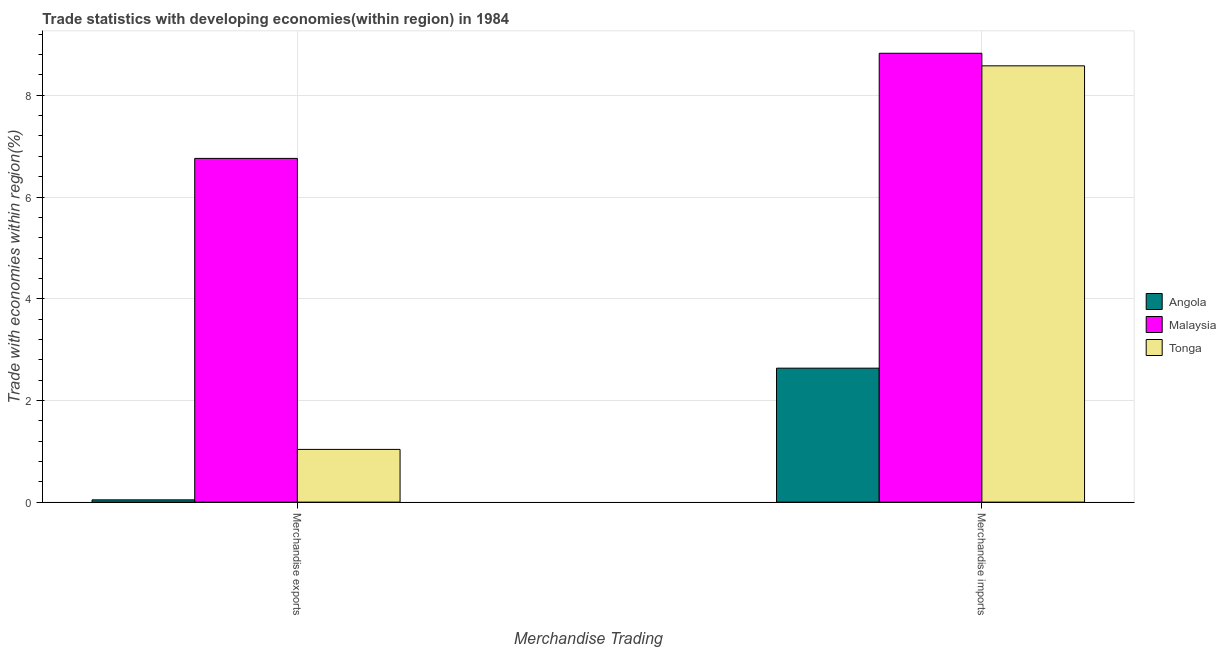How many different coloured bars are there?
Provide a succinct answer. 3. Are the number of bars per tick equal to the number of legend labels?
Ensure brevity in your answer.  Yes. How many bars are there on the 2nd tick from the left?
Ensure brevity in your answer.  3. How many bars are there on the 1st tick from the right?
Give a very brief answer. 3. What is the merchandise imports in Tonga?
Keep it short and to the point. 8.58. Across all countries, what is the maximum merchandise exports?
Ensure brevity in your answer.  6.76. Across all countries, what is the minimum merchandise imports?
Give a very brief answer. 2.63. In which country was the merchandise imports maximum?
Offer a very short reply. Malaysia. In which country was the merchandise exports minimum?
Provide a short and direct response. Angola. What is the total merchandise imports in the graph?
Your answer should be very brief. 20.04. What is the difference between the merchandise imports in Tonga and that in Angola?
Your response must be concise. 5.95. What is the difference between the merchandise imports in Angola and the merchandise exports in Malaysia?
Provide a succinct answer. -4.12. What is the average merchandise exports per country?
Give a very brief answer. 2.61. What is the difference between the merchandise exports and merchandise imports in Angola?
Give a very brief answer. -2.59. In how many countries, is the merchandise imports greater than 6 %?
Provide a succinct answer. 2. What is the ratio of the merchandise exports in Angola to that in Tonga?
Make the answer very short. 0.04. Is the merchandise exports in Malaysia less than that in Angola?
Your answer should be very brief. No. What does the 2nd bar from the left in Merchandise imports represents?
Your answer should be very brief. Malaysia. What does the 1st bar from the right in Merchandise exports represents?
Give a very brief answer. Tonga. How many countries are there in the graph?
Make the answer very short. 3. What is the difference between two consecutive major ticks on the Y-axis?
Your response must be concise. 2. Are the values on the major ticks of Y-axis written in scientific E-notation?
Ensure brevity in your answer.  No. How many legend labels are there?
Provide a short and direct response. 3. What is the title of the graph?
Keep it short and to the point. Trade statistics with developing economies(within region) in 1984. Does "Arab World" appear as one of the legend labels in the graph?
Offer a very short reply. No. What is the label or title of the X-axis?
Your answer should be very brief. Merchandise Trading. What is the label or title of the Y-axis?
Provide a succinct answer. Trade with economies within region(%). What is the Trade with economies within region(%) in Angola in Merchandise exports?
Your answer should be compact. 0.04. What is the Trade with economies within region(%) in Malaysia in Merchandise exports?
Your response must be concise. 6.76. What is the Trade with economies within region(%) of Tonga in Merchandise exports?
Offer a terse response. 1.04. What is the Trade with economies within region(%) of Angola in Merchandise imports?
Provide a succinct answer. 2.63. What is the Trade with economies within region(%) of Malaysia in Merchandise imports?
Provide a succinct answer. 8.83. What is the Trade with economies within region(%) of Tonga in Merchandise imports?
Keep it short and to the point. 8.58. Across all Merchandise Trading, what is the maximum Trade with economies within region(%) in Angola?
Provide a succinct answer. 2.63. Across all Merchandise Trading, what is the maximum Trade with economies within region(%) in Malaysia?
Your answer should be very brief. 8.83. Across all Merchandise Trading, what is the maximum Trade with economies within region(%) of Tonga?
Offer a terse response. 8.58. Across all Merchandise Trading, what is the minimum Trade with economies within region(%) of Angola?
Your answer should be very brief. 0.04. Across all Merchandise Trading, what is the minimum Trade with economies within region(%) of Malaysia?
Make the answer very short. 6.76. Across all Merchandise Trading, what is the minimum Trade with economies within region(%) of Tonga?
Make the answer very short. 1.04. What is the total Trade with economies within region(%) of Angola in the graph?
Provide a succinct answer. 2.68. What is the total Trade with economies within region(%) of Malaysia in the graph?
Provide a short and direct response. 15.59. What is the total Trade with economies within region(%) of Tonga in the graph?
Make the answer very short. 9.62. What is the difference between the Trade with economies within region(%) in Angola in Merchandise exports and that in Merchandise imports?
Provide a short and direct response. -2.59. What is the difference between the Trade with economies within region(%) of Malaysia in Merchandise exports and that in Merchandise imports?
Provide a succinct answer. -2.07. What is the difference between the Trade with economies within region(%) in Tonga in Merchandise exports and that in Merchandise imports?
Give a very brief answer. -7.54. What is the difference between the Trade with economies within region(%) of Angola in Merchandise exports and the Trade with economies within region(%) of Malaysia in Merchandise imports?
Make the answer very short. -8.78. What is the difference between the Trade with economies within region(%) in Angola in Merchandise exports and the Trade with economies within region(%) in Tonga in Merchandise imports?
Ensure brevity in your answer.  -8.54. What is the difference between the Trade with economies within region(%) in Malaysia in Merchandise exports and the Trade with economies within region(%) in Tonga in Merchandise imports?
Offer a terse response. -1.82. What is the average Trade with economies within region(%) in Angola per Merchandise Trading?
Ensure brevity in your answer.  1.34. What is the average Trade with economies within region(%) in Malaysia per Merchandise Trading?
Keep it short and to the point. 7.79. What is the average Trade with economies within region(%) of Tonga per Merchandise Trading?
Provide a succinct answer. 4.81. What is the difference between the Trade with economies within region(%) in Angola and Trade with economies within region(%) in Malaysia in Merchandise exports?
Your answer should be very brief. -6.71. What is the difference between the Trade with economies within region(%) of Angola and Trade with economies within region(%) of Tonga in Merchandise exports?
Your response must be concise. -0.99. What is the difference between the Trade with economies within region(%) in Malaysia and Trade with economies within region(%) in Tonga in Merchandise exports?
Offer a very short reply. 5.72. What is the difference between the Trade with economies within region(%) of Angola and Trade with economies within region(%) of Malaysia in Merchandise imports?
Keep it short and to the point. -6.19. What is the difference between the Trade with economies within region(%) of Angola and Trade with economies within region(%) of Tonga in Merchandise imports?
Your answer should be compact. -5.95. What is the difference between the Trade with economies within region(%) in Malaysia and Trade with economies within region(%) in Tonga in Merchandise imports?
Make the answer very short. 0.25. What is the ratio of the Trade with economies within region(%) in Angola in Merchandise exports to that in Merchandise imports?
Ensure brevity in your answer.  0.02. What is the ratio of the Trade with economies within region(%) in Malaysia in Merchandise exports to that in Merchandise imports?
Provide a short and direct response. 0.77. What is the ratio of the Trade with economies within region(%) of Tonga in Merchandise exports to that in Merchandise imports?
Offer a very short reply. 0.12. What is the difference between the highest and the second highest Trade with economies within region(%) in Angola?
Give a very brief answer. 2.59. What is the difference between the highest and the second highest Trade with economies within region(%) of Malaysia?
Make the answer very short. 2.07. What is the difference between the highest and the second highest Trade with economies within region(%) of Tonga?
Give a very brief answer. 7.54. What is the difference between the highest and the lowest Trade with economies within region(%) of Angola?
Your answer should be compact. 2.59. What is the difference between the highest and the lowest Trade with economies within region(%) of Malaysia?
Keep it short and to the point. 2.07. What is the difference between the highest and the lowest Trade with economies within region(%) in Tonga?
Offer a terse response. 7.54. 